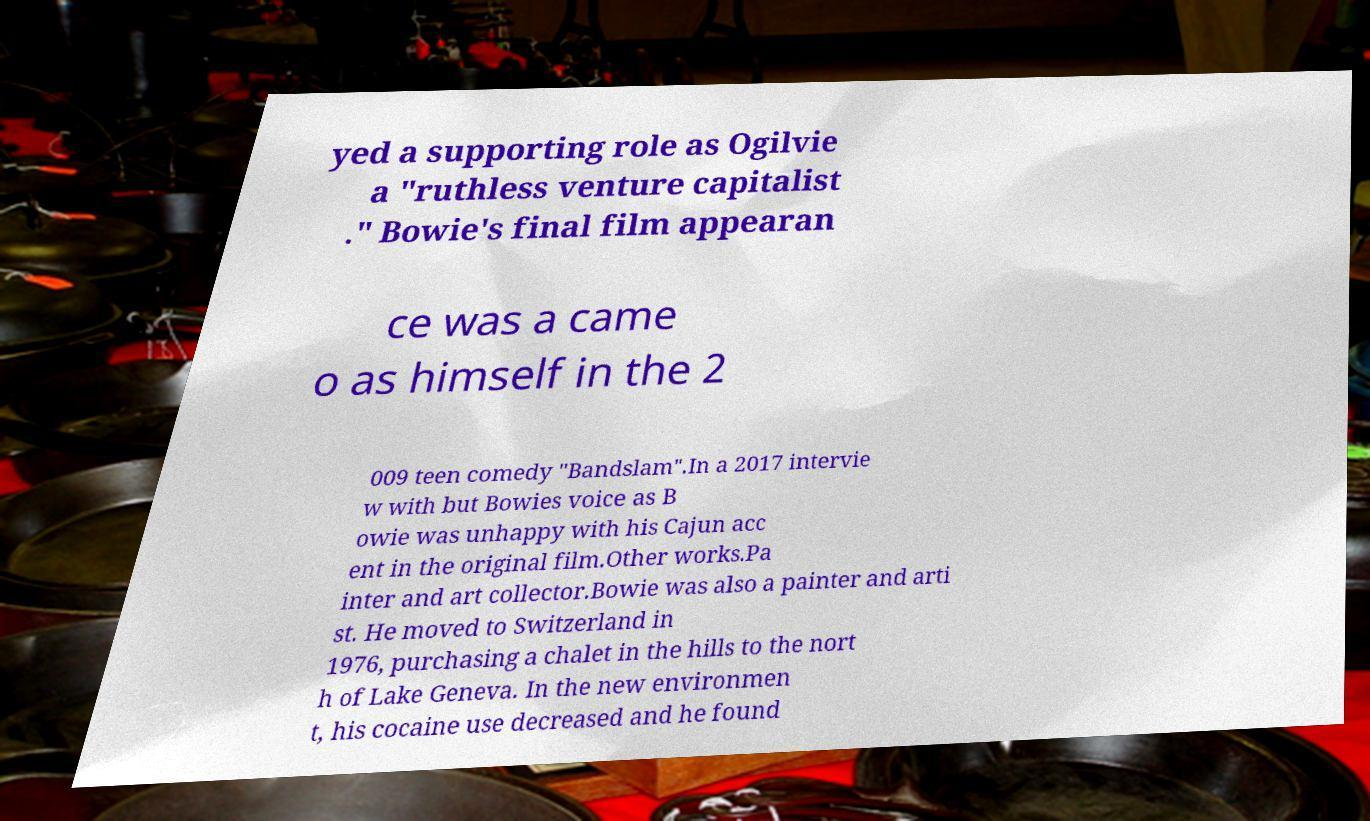Please read and relay the text visible in this image. What does it say? yed a supporting role as Ogilvie a "ruthless venture capitalist ." Bowie's final film appearan ce was a came o as himself in the 2 009 teen comedy "Bandslam".In a 2017 intervie w with but Bowies voice as B owie was unhappy with his Cajun acc ent in the original film.Other works.Pa inter and art collector.Bowie was also a painter and arti st. He moved to Switzerland in 1976, purchasing a chalet in the hills to the nort h of Lake Geneva. In the new environmen t, his cocaine use decreased and he found 